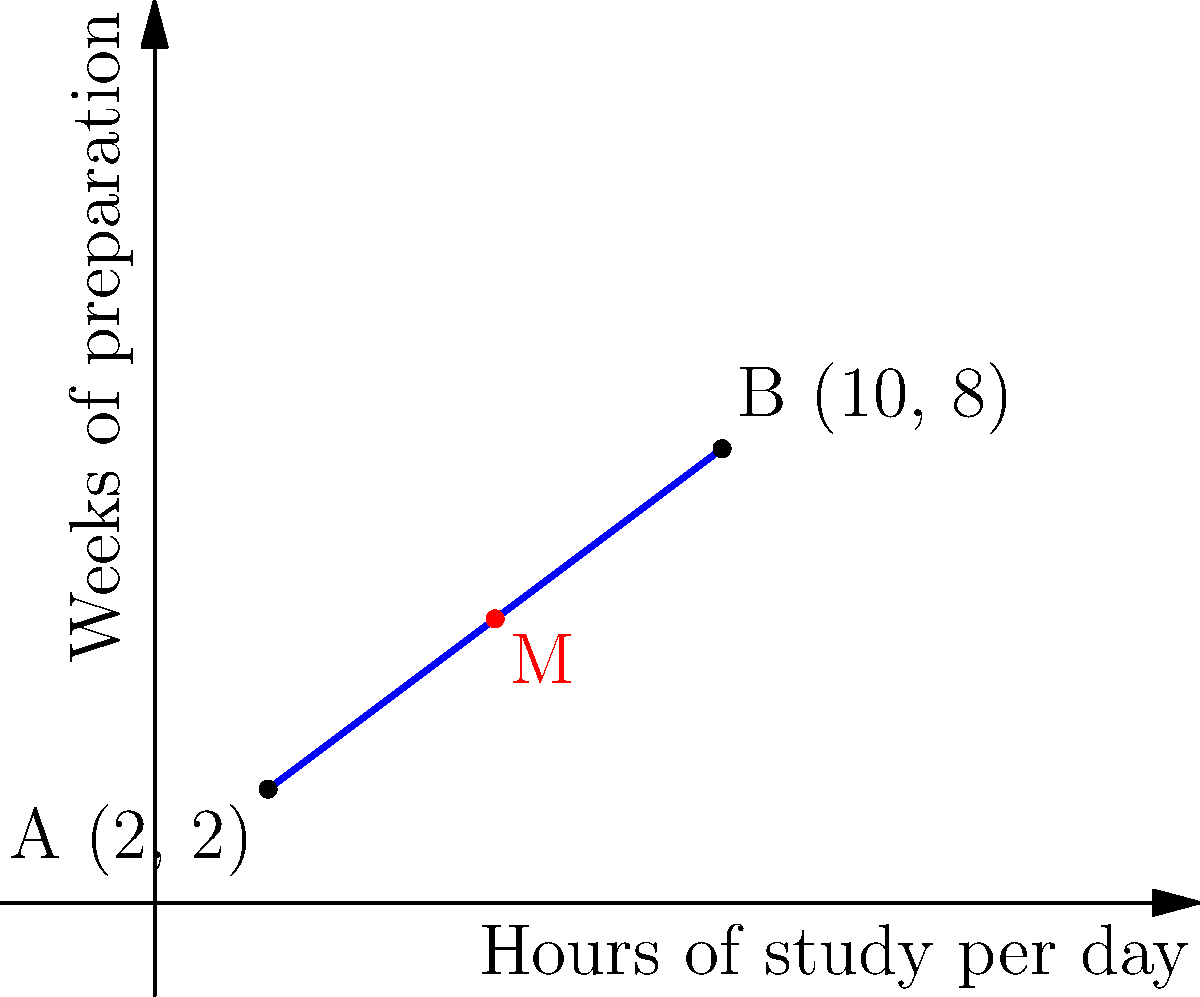A pre-med student is planning their MCAT preparation schedule. The graph shows a line segment representing the relationship between daily study hours and weeks of preparation. Point A (2, 2) represents a minimal preparation plan, while point B (10, 8) represents an intensive plan. What are the coordinates of the midpoint M, which represents a balanced approach to MCAT preparation? To find the midpoint of a line segment, we can use the midpoint formula:

$$ M_x = \frac{x_1 + x_2}{2}, \quad M_y = \frac{y_1 + y_2}{2} $$

Where $(x_1, y_1)$ and $(x_2, y_2)$ are the coordinates of the endpoints.

For this problem:
1. Point A: $(x_1, y_1) = (2, 2)$
2. Point B: $(x_2, y_2) = (10, 8)$

Let's calculate the x-coordinate of the midpoint:
$$ M_x = \frac{x_1 + x_2}{2} = \frac{2 + 10}{2} = \frac{12}{2} = 6 $$

Now, let's calculate the y-coordinate of the midpoint:
$$ M_y = \frac{y_1 + y_2}{2} = \frac{2 + 8}{2} = \frac{10}{2} = 5 $$

Therefore, the coordinates of the midpoint M are (6, 5).

Interpreting the result:
- The x-coordinate (6) represents 6 hours of study per day.
- The y-coordinate (5) represents 5 weeks of preparation.

This midpoint represents a balanced approach to MCAT preparation, with moderate daily study hours over a medium-length preparation period.
Answer: (6, 5) 